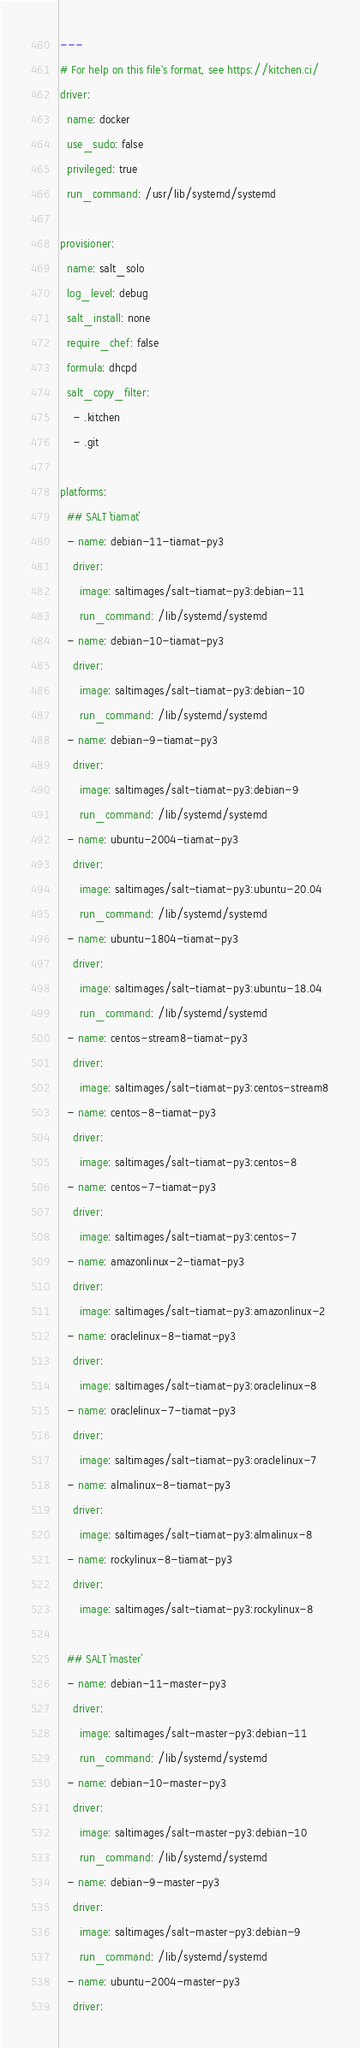Convert code to text. <code><loc_0><loc_0><loc_500><loc_500><_YAML_>---
# For help on this file's format, see https://kitchen.ci/
driver:
  name: docker
  use_sudo: false
  privileged: true
  run_command: /usr/lib/systemd/systemd

provisioner:
  name: salt_solo
  log_level: debug
  salt_install: none
  require_chef: false
  formula: dhcpd
  salt_copy_filter:
    - .kitchen
    - .git

platforms:
  ## SALT `tiamat`
  - name: debian-11-tiamat-py3
    driver:
      image: saltimages/salt-tiamat-py3:debian-11
      run_command: /lib/systemd/systemd
  - name: debian-10-tiamat-py3
    driver:
      image: saltimages/salt-tiamat-py3:debian-10
      run_command: /lib/systemd/systemd
  - name: debian-9-tiamat-py3
    driver:
      image: saltimages/salt-tiamat-py3:debian-9
      run_command: /lib/systemd/systemd
  - name: ubuntu-2004-tiamat-py3
    driver:
      image: saltimages/salt-tiamat-py3:ubuntu-20.04
      run_command: /lib/systemd/systemd
  - name: ubuntu-1804-tiamat-py3
    driver:
      image: saltimages/salt-tiamat-py3:ubuntu-18.04
      run_command: /lib/systemd/systemd
  - name: centos-stream8-tiamat-py3
    driver:
      image: saltimages/salt-tiamat-py3:centos-stream8
  - name: centos-8-tiamat-py3
    driver:
      image: saltimages/salt-tiamat-py3:centos-8
  - name: centos-7-tiamat-py3
    driver:
      image: saltimages/salt-tiamat-py3:centos-7
  - name: amazonlinux-2-tiamat-py3
    driver:
      image: saltimages/salt-tiamat-py3:amazonlinux-2
  - name: oraclelinux-8-tiamat-py3
    driver:
      image: saltimages/salt-tiamat-py3:oraclelinux-8
  - name: oraclelinux-7-tiamat-py3
    driver:
      image: saltimages/salt-tiamat-py3:oraclelinux-7
  - name: almalinux-8-tiamat-py3
    driver:
      image: saltimages/salt-tiamat-py3:almalinux-8
  - name: rockylinux-8-tiamat-py3
    driver:
      image: saltimages/salt-tiamat-py3:rockylinux-8

  ## SALT `master`
  - name: debian-11-master-py3
    driver:
      image: saltimages/salt-master-py3:debian-11
      run_command: /lib/systemd/systemd
  - name: debian-10-master-py3
    driver:
      image: saltimages/salt-master-py3:debian-10
      run_command: /lib/systemd/systemd
  - name: debian-9-master-py3
    driver:
      image: saltimages/salt-master-py3:debian-9
      run_command: /lib/systemd/systemd
  - name: ubuntu-2004-master-py3
    driver:</code> 